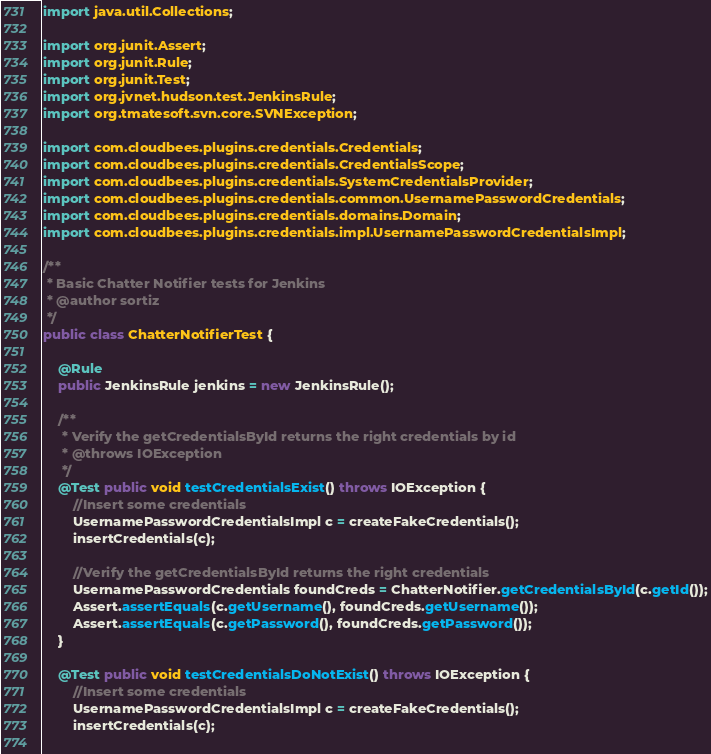Convert code to text. <code><loc_0><loc_0><loc_500><loc_500><_Java_>import java.util.Collections;

import org.junit.Assert;
import org.junit.Rule;
import org.junit.Test;
import org.jvnet.hudson.test.JenkinsRule;
import org.tmatesoft.svn.core.SVNException;

import com.cloudbees.plugins.credentials.Credentials;
import com.cloudbees.plugins.credentials.CredentialsScope;
import com.cloudbees.plugins.credentials.SystemCredentialsProvider;
import com.cloudbees.plugins.credentials.common.UsernamePasswordCredentials;
import com.cloudbees.plugins.credentials.domains.Domain;
import com.cloudbees.plugins.credentials.impl.UsernamePasswordCredentialsImpl;

/**
 * Basic Chatter Notifier tests for Jenkins
 * @author sortiz
 */
public class ChatterNotifierTest {
	
	@Rule
	public JenkinsRule jenkins = new JenkinsRule();
	
	/**
	 * Verify the getCredentialsById returns the right credentials by id
	 * @throws IOException
	 */
	@Test public void testCredentialsExist() throws IOException {
		//Insert some credentials
		UsernamePasswordCredentialsImpl c = createFakeCredentials();
		insertCredentials(c);
		
		//Verify the getCredentialsById returns the right credentials
		UsernamePasswordCredentials foundCreds = ChatterNotifier.getCredentialsById(c.getId());
		Assert.assertEquals(c.getUsername(), foundCreds.getUsername());
		Assert.assertEquals(c.getPassword(), foundCreds.getPassword());
	}
	
	@Test public void testCredentialsDoNotExist() throws IOException {
		//Insert some credentials
		UsernamePasswordCredentialsImpl c = createFakeCredentials();
		insertCredentials(c);
		</code> 